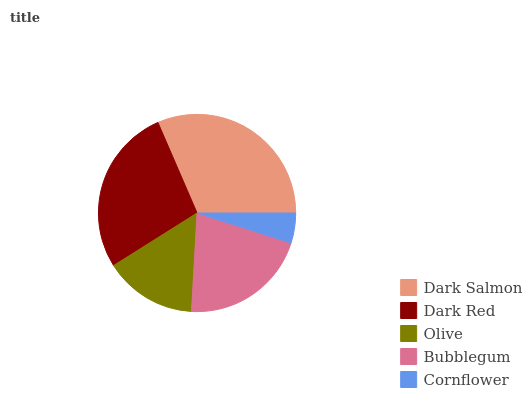Is Cornflower the minimum?
Answer yes or no. Yes. Is Dark Salmon the maximum?
Answer yes or no. Yes. Is Dark Red the minimum?
Answer yes or no. No. Is Dark Red the maximum?
Answer yes or no. No. Is Dark Salmon greater than Dark Red?
Answer yes or no. Yes. Is Dark Red less than Dark Salmon?
Answer yes or no. Yes. Is Dark Red greater than Dark Salmon?
Answer yes or no. No. Is Dark Salmon less than Dark Red?
Answer yes or no. No. Is Bubblegum the high median?
Answer yes or no. Yes. Is Bubblegum the low median?
Answer yes or no. Yes. Is Dark Salmon the high median?
Answer yes or no. No. Is Dark Red the low median?
Answer yes or no. No. 